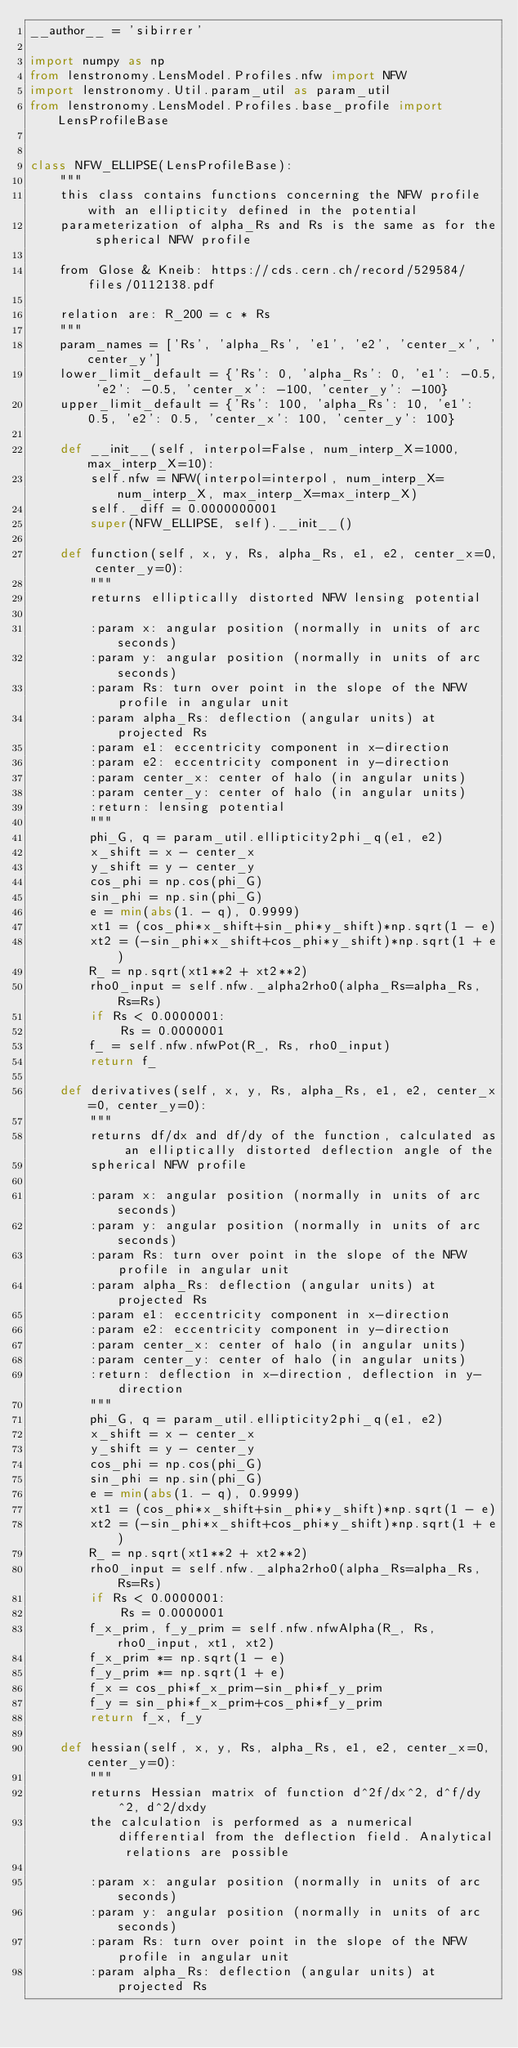Convert code to text. <code><loc_0><loc_0><loc_500><loc_500><_Python_>__author__ = 'sibirrer'

import numpy as np
from lenstronomy.LensModel.Profiles.nfw import NFW
import lenstronomy.Util.param_util as param_util
from lenstronomy.LensModel.Profiles.base_profile import LensProfileBase


class NFW_ELLIPSE(LensProfileBase):
    """
    this class contains functions concerning the NFW profile with an ellipticity defined in the potential
    parameterization of alpha_Rs and Rs is the same as for the spherical NFW profile

    from Glose & Kneib: https://cds.cern.ch/record/529584/files/0112138.pdf

    relation are: R_200 = c * Rs
    """
    param_names = ['Rs', 'alpha_Rs', 'e1', 'e2', 'center_x', 'center_y']
    lower_limit_default = {'Rs': 0, 'alpha_Rs': 0, 'e1': -0.5, 'e2': -0.5, 'center_x': -100, 'center_y': -100}
    upper_limit_default = {'Rs': 100, 'alpha_Rs': 10, 'e1': 0.5, 'e2': 0.5, 'center_x': 100, 'center_y': 100}

    def __init__(self, interpol=False, num_interp_X=1000, max_interp_X=10):
        self.nfw = NFW(interpol=interpol, num_interp_X=num_interp_X, max_interp_X=max_interp_X)
        self._diff = 0.0000000001
        super(NFW_ELLIPSE, self).__init__()

    def function(self, x, y, Rs, alpha_Rs, e1, e2, center_x=0, center_y=0):
        """
        returns elliptically distorted NFW lensing potential

        :param x: angular position (normally in units of arc seconds)
        :param y: angular position (normally in units of arc seconds)
        :param Rs: turn over point in the slope of the NFW profile in angular unit
        :param alpha_Rs: deflection (angular units) at projected Rs
        :param e1: eccentricity component in x-direction
        :param e2: eccentricity component in y-direction
        :param center_x: center of halo (in angular units)
        :param center_y: center of halo (in angular units)
        :return: lensing potential
        """
        phi_G, q = param_util.ellipticity2phi_q(e1, e2)
        x_shift = x - center_x
        y_shift = y - center_y
        cos_phi = np.cos(phi_G)
        sin_phi = np.sin(phi_G)
        e = min(abs(1. - q), 0.9999)
        xt1 = (cos_phi*x_shift+sin_phi*y_shift)*np.sqrt(1 - e)
        xt2 = (-sin_phi*x_shift+cos_phi*y_shift)*np.sqrt(1 + e)
        R_ = np.sqrt(xt1**2 + xt2**2)
        rho0_input = self.nfw._alpha2rho0(alpha_Rs=alpha_Rs, Rs=Rs)
        if Rs < 0.0000001:
            Rs = 0.0000001
        f_ = self.nfw.nfwPot(R_, Rs, rho0_input)
        return f_

    def derivatives(self, x, y, Rs, alpha_Rs, e1, e2, center_x=0, center_y=0):
        """
        returns df/dx and df/dy of the function, calculated as an elliptically distorted deflection angle of the
        spherical NFW profile

        :param x: angular position (normally in units of arc seconds)
        :param y: angular position (normally in units of arc seconds)
        :param Rs: turn over point in the slope of the NFW profile in angular unit
        :param alpha_Rs: deflection (angular units) at projected Rs
        :param e1: eccentricity component in x-direction
        :param e2: eccentricity component in y-direction
        :param center_x: center of halo (in angular units)
        :param center_y: center of halo (in angular units)
        :return: deflection in x-direction, deflection in y-direction
        """
        phi_G, q = param_util.ellipticity2phi_q(e1, e2)
        x_shift = x - center_x
        y_shift = y - center_y
        cos_phi = np.cos(phi_G)
        sin_phi = np.sin(phi_G)
        e = min(abs(1. - q), 0.9999)
        xt1 = (cos_phi*x_shift+sin_phi*y_shift)*np.sqrt(1 - e)
        xt2 = (-sin_phi*x_shift+cos_phi*y_shift)*np.sqrt(1 + e)
        R_ = np.sqrt(xt1**2 + xt2**2)
        rho0_input = self.nfw._alpha2rho0(alpha_Rs=alpha_Rs, Rs=Rs)
        if Rs < 0.0000001:
            Rs = 0.0000001
        f_x_prim, f_y_prim = self.nfw.nfwAlpha(R_, Rs, rho0_input, xt1, xt2)
        f_x_prim *= np.sqrt(1 - e)
        f_y_prim *= np.sqrt(1 + e)
        f_x = cos_phi*f_x_prim-sin_phi*f_y_prim
        f_y = sin_phi*f_x_prim+cos_phi*f_y_prim
        return f_x, f_y

    def hessian(self, x, y, Rs, alpha_Rs, e1, e2, center_x=0, center_y=0):
        """
        returns Hessian matrix of function d^2f/dx^2, d^f/dy^2, d^2/dxdy
        the calculation is performed as a numerical differential from the deflection field. Analytical relations are possible

        :param x: angular position (normally in units of arc seconds)
        :param y: angular position (normally in units of arc seconds)
        :param Rs: turn over point in the slope of the NFW profile in angular unit
        :param alpha_Rs: deflection (angular units) at projected Rs</code> 